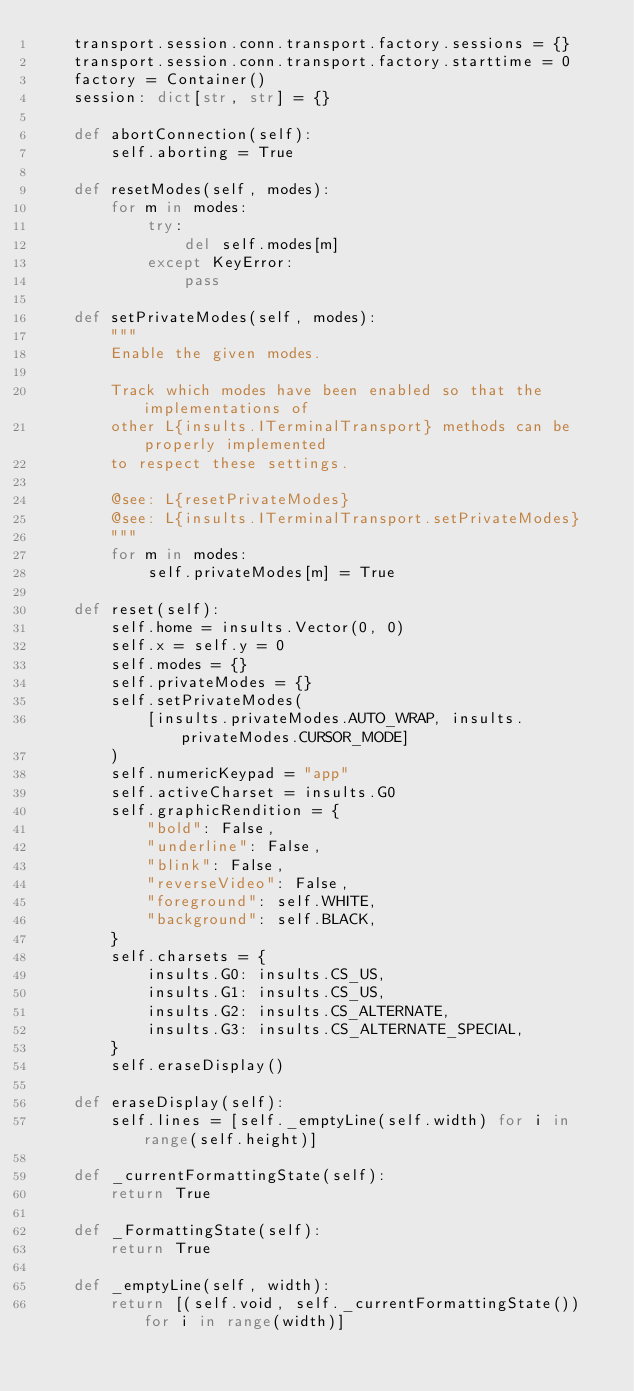<code> <loc_0><loc_0><loc_500><loc_500><_Python_>    transport.session.conn.transport.factory.sessions = {}
    transport.session.conn.transport.factory.starttime = 0
    factory = Container()
    session: dict[str, str] = {}

    def abortConnection(self):
        self.aborting = True

    def resetModes(self, modes):
        for m in modes:
            try:
                del self.modes[m]
            except KeyError:
                pass

    def setPrivateModes(self, modes):
        """
        Enable the given modes.

        Track which modes have been enabled so that the implementations of
        other L{insults.ITerminalTransport} methods can be properly implemented
        to respect these settings.

        @see: L{resetPrivateModes}
        @see: L{insults.ITerminalTransport.setPrivateModes}
        """
        for m in modes:
            self.privateModes[m] = True

    def reset(self):
        self.home = insults.Vector(0, 0)
        self.x = self.y = 0
        self.modes = {}
        self.privateModes = {}
        self.setPrivateModes(
            [insults.privateModes.AUTO_WRAP, insults.privateModes.CURSOR_MODE]
        )
        self.numericKeypad = "app"
        self.activeCharset = insults.G0
        self.graphicRendition = {
            "bold": False,
            "underline": False,
            "blink": False,
            "reverseVideo": False,
            "foreground": self.WHITE,
            "background": self.BLACK,
        }
        self.charsets = {
            insults.G0: insults.CS_US,
            insults.G1: insults.CS_US,
            insults.G2: insults.CS_ALTERNATE,
            insults.G3: insults.CS_ALTERNATE_SPECIAL,
        }
        self.eraseDisplay()

    def eraseDisplay(self):
        self.lines = [self._emptyLine(self.width) for i in range(self.height)]

    def _currentFormattingState(self):
        return True

    def _FormattingState(self):
        return True

    def _emptyLine(self, width):
        return [(self.void, self._currentFormattingState()) for i in range(width)]
</code> 